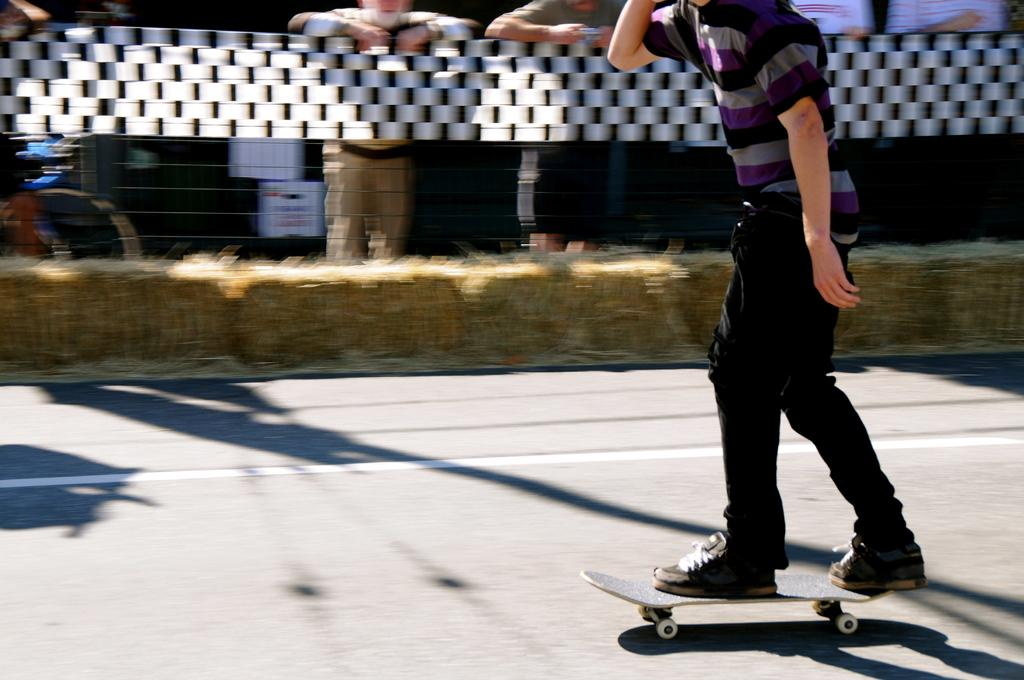What is the person in the image doing? There is a person skating on the road in the image. Can you describe the surroundings of the person? There are people in the background of the image, as well as a fence, posters, and other objects. How many people are visible in the background? There are people in the background of the image, but the exact number is not specified. What type of objects can be seen in the background? In addition to the fence and posters, there are other objects present in the background of the image. Can you see any quivers in the image? There is no mention of quivers in the image. 